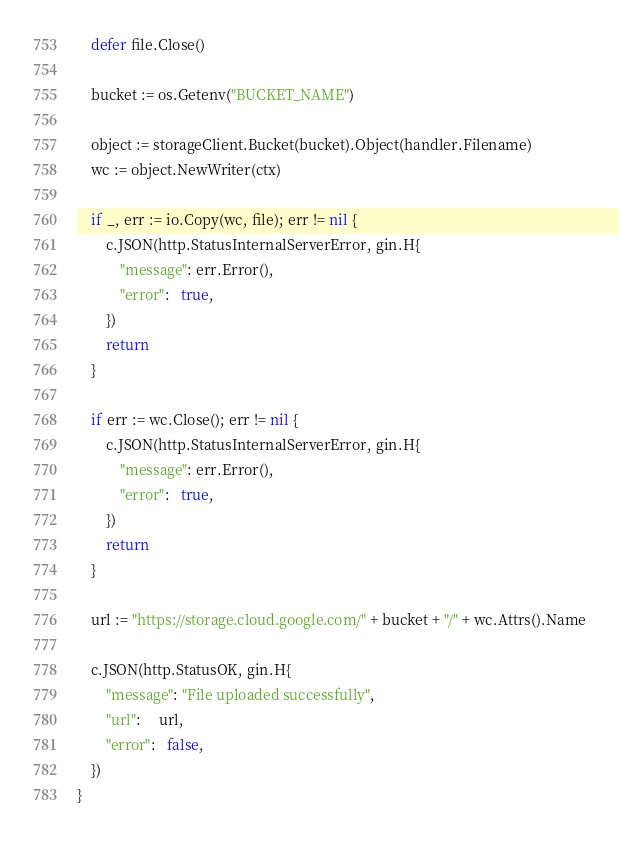Convert code to text. <code><loc_0><loc_0><loc_500><loc_500><_Go_>	defer file.Close()

	bucket := os.Getenv("BUCKET_NAME")

	object := storageClient.Bucket(bucket).Object(handler.Filename)
	wc := object.NewWriter(ctx)

	if _, err := io.Copy(wc, file); err != nil {
		c.JSON(http.StatusInternalServerError, gin.H{
			"message": err.Error(),
			"error":   true,
		})
		return
	}

	if err := wc.Close(); err != nil {
		c.JSON(http.StatusInternalServerError, gin.H{
			"message": err.Error(),
			"error":   true,
		})
		return
	}

	url := "https://storage.cloud.google.com/" + bucket + "/" + wc.Attrs().Name

	c.JSON(http.StatusOK, gin.H{
		"message": "File uploaded successfully",
		"url":     url,
		"error":   false,
	})
}
</code> 